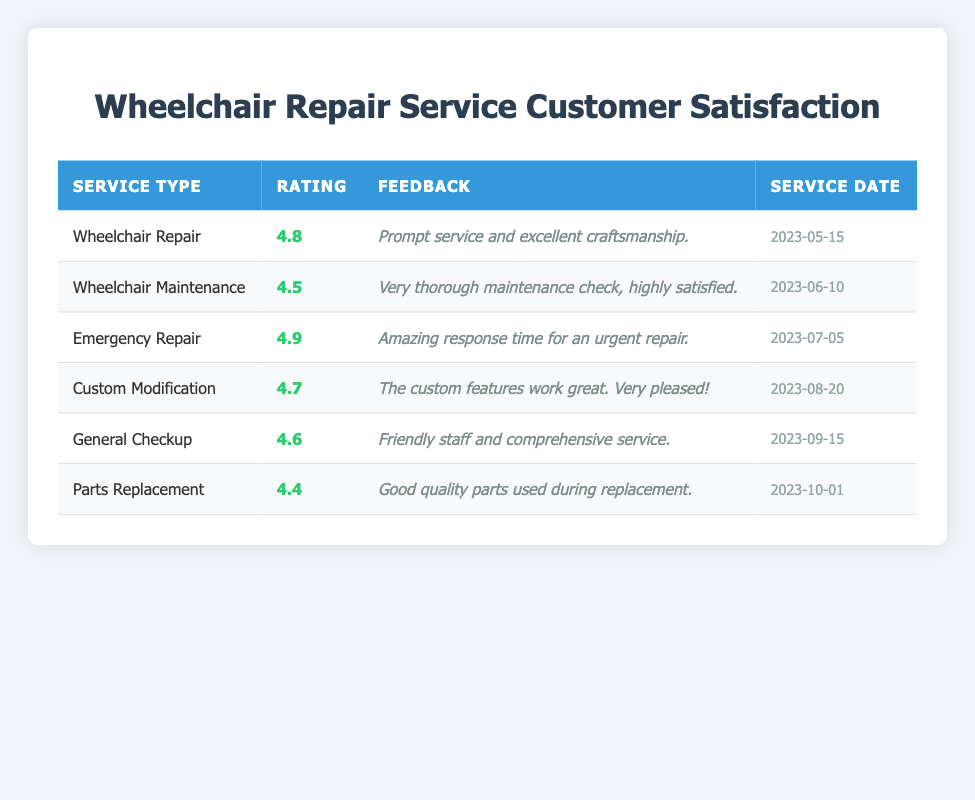What is the highest rating score among the services provided? The table lists the rating scores for each service. Scanning through the ratings, the highest score is 4.9 for the "Emergency Repair" service.
Answer: 4.9 How many services received a rating score of 4.5 or higher? By counting the services listed in the table, there are a total of 5 services with ratings of 4.5 or higher: Wheelchair Repair (4.8), Wheelchair Maintenance (4.5), Emergency Repair (4.9), Custom Modification (4.7), and General Checkup (4.6).
Answer: 5 Did any customers express dissatisfaction with the quality of service? The feedback provided for all services shows positive sentiments. There are no comments indicating dissatisfaction, thus it is true that no customer expressed dissatisfaction.
Answer: Yes What is the average rating score for all the services combined? To find the average rating, sum all the rating scores: 4.8 + 4.5 + 4.9 + 4.7 + 4.6 + 4.4 = 28.8. There are 6 services, so the average is 28.8 / 6 = 4.8.
Answer: 4.8 Which service type received the lowest rating? The ratings of all services are compared: the "Parts Replacement" service has the lowest score at 4.4 compared to the others.
Answer: Parts Replacement What feedback did the customer who received a "General Checkup" service provide? The feedback for the "General Checkup" service states: "Friendly staff and comprehensive service," which indicates a positive experience.
Answer: Friendly staff and comprehensive service Were there more ratings for Wheelchair Repair services than for Parts Replacement services? The table shows that there is 1 entry for "Wheelchair Repair" and 1 entry for "Parts Replacement." Thus, they are equal in the number of ratings.
Answer: No What was the service date for the customer who provided feedback on "Custom Modification"? According to the table, the service date for "Custom Modification" is "2023-08-20."
Answer: 2023-08-20 How many services listed had feedback mentioning the responsiveness of the service? The feedback for "Emergency Repair" specifically mentions "Amazing response time for an urgent repair." This is the only service with such a comment, resulting in a count of 1.
Answer: 1 